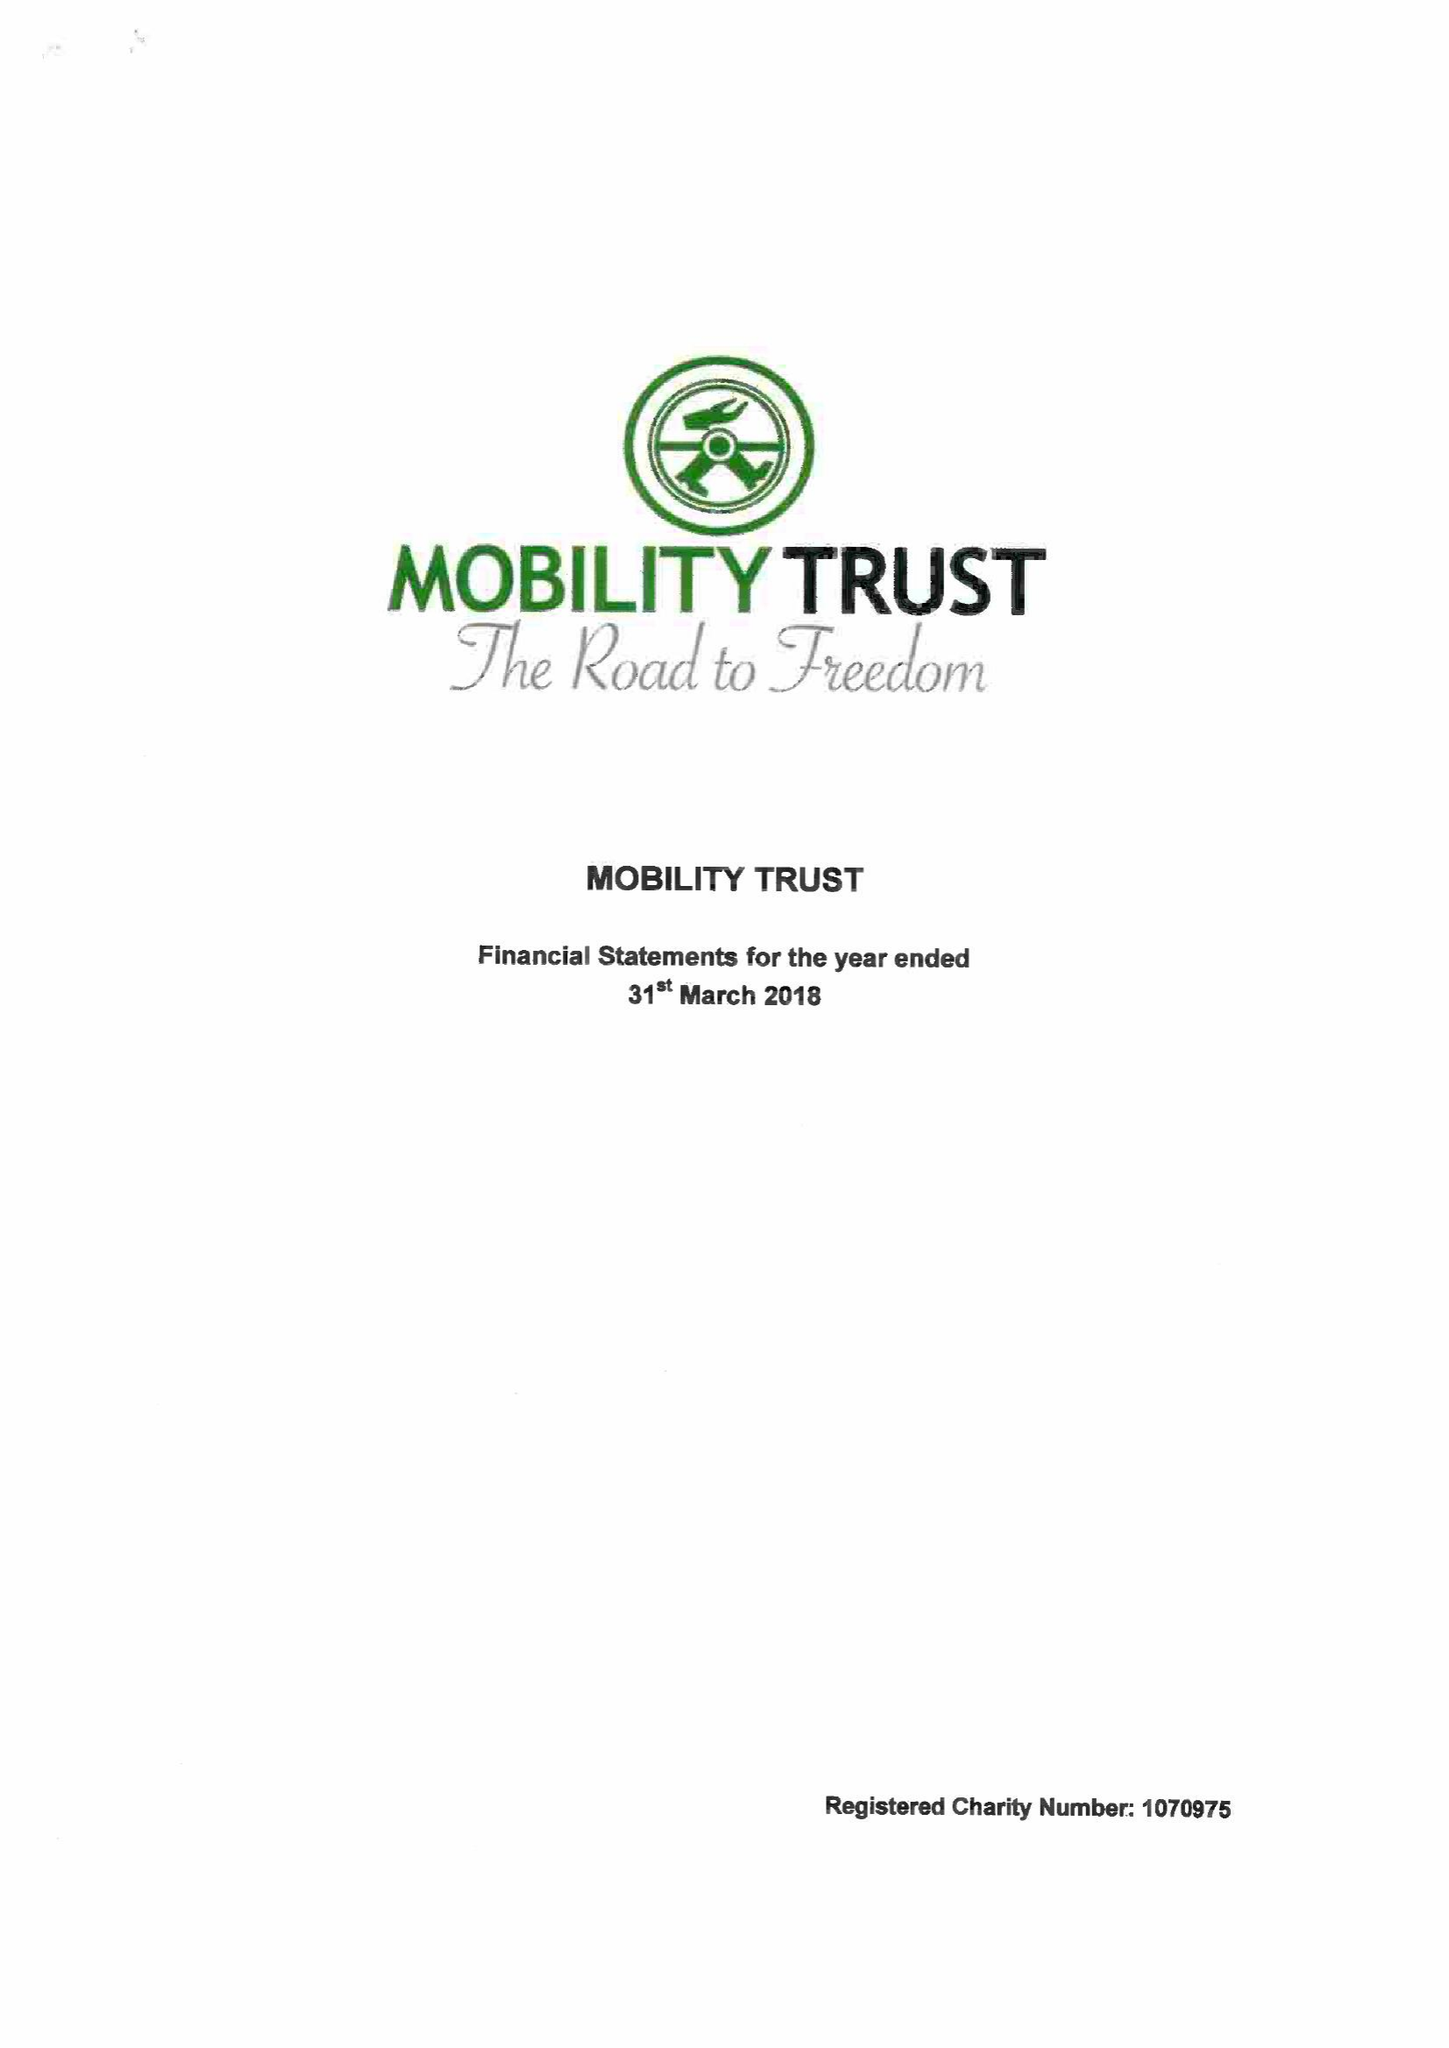What is the value for the charity_name?
Answer the question using a single word or phrase. Mobility Trust Ii 